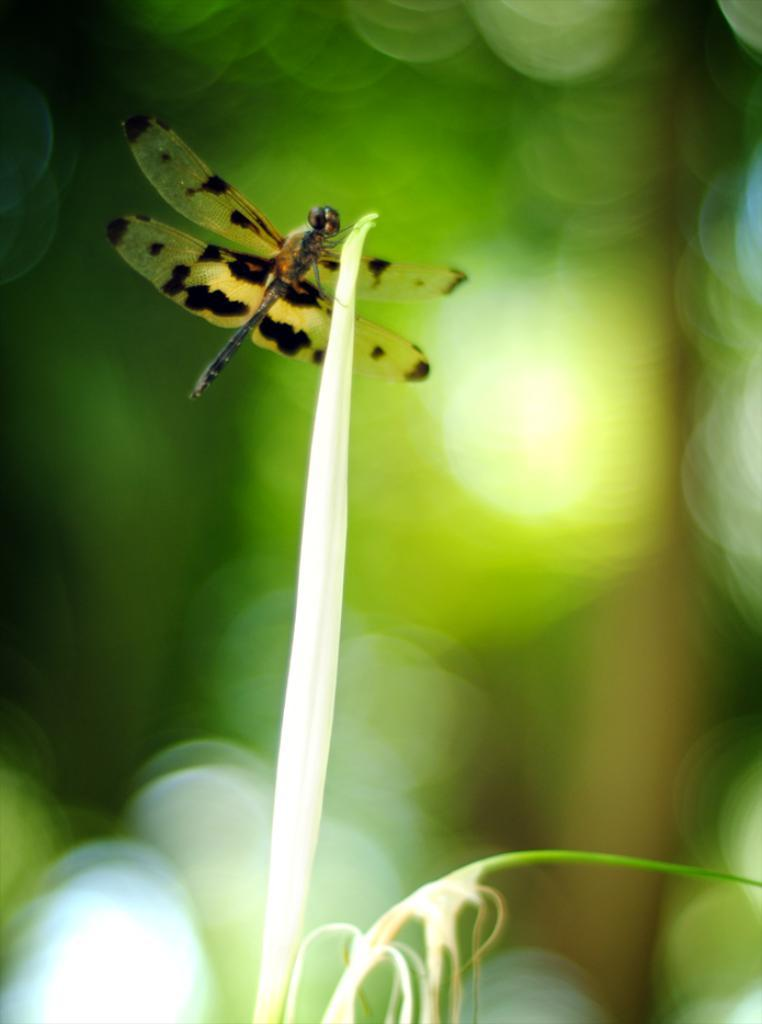What is the main subject of the image? There is a dragonfly in the image. Where is the dragonfly located? The dragonfly is on a plant. Can you describe the background of the image? The background of the image is blurry. What type of wood is the apple resting on in the image? There is no apple or wood present in the image; it features a dragonfly on a plant with a blurry background. 